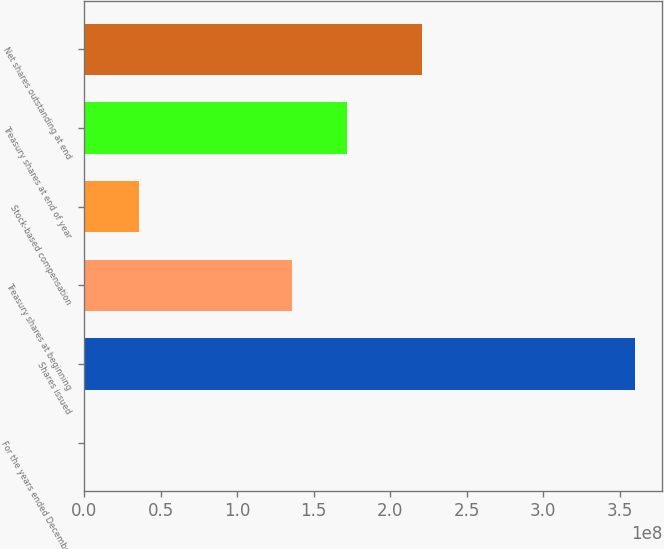Convert chart. <chart><loc_0><loc_0><loc_500><loc_500><bar_chart><fcel>For the years ended December<fcel>Shares issued<fcel>Treasury shares at beginning<fcel>Stock-based compensation<fcel>Treasury shares at end of year<fcel>Net shares outstanding at end<nl><fcel>2014<fcel>3.59902e+08<fcel>1.36007e+08<fcel>3.5992e+07<fcel>1.71997e+08<fcel>2.21045e+08<nl></chart> 